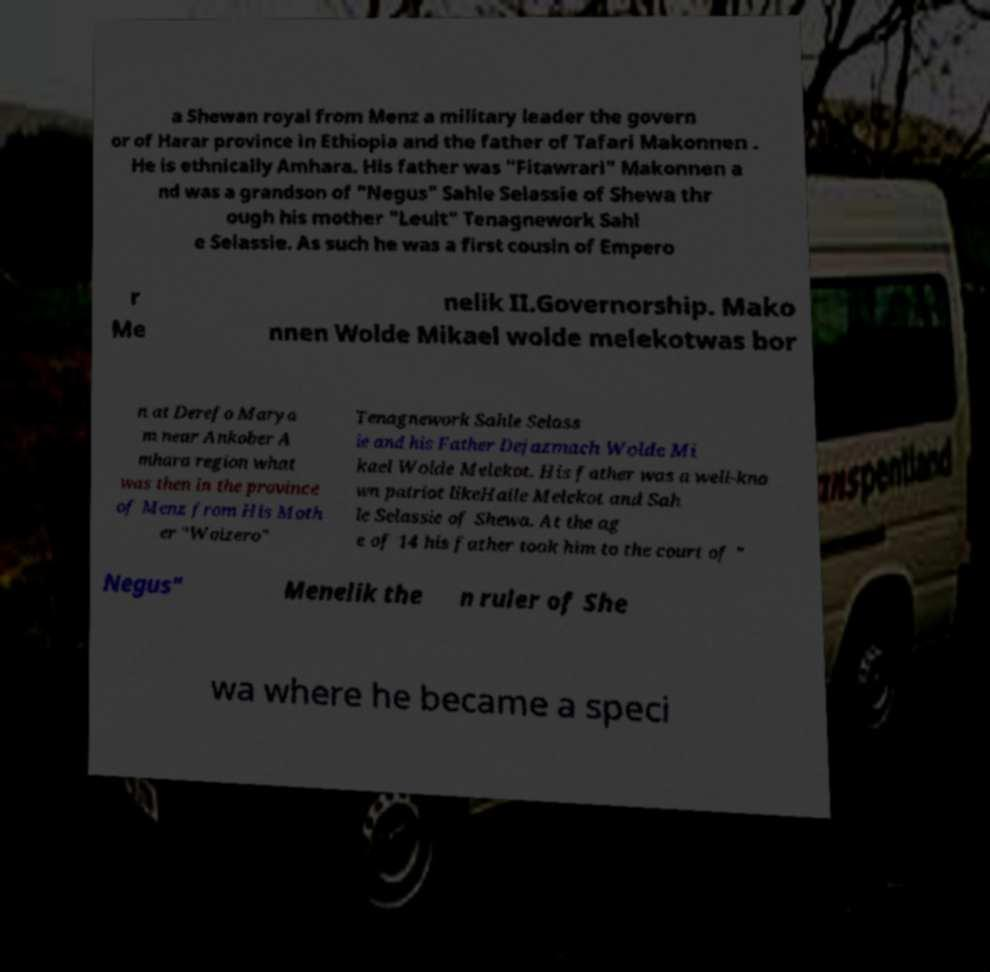There's text embedded in this image that I need extracted. Can you transcribe it verbatim? a Shewan royal from Menz a military leader the govern or of Harar province in Ethiopia and the father of Tafari Makonnen . He is ethnically Amhara. His father was "Fitawrari" Makonnen a nd was a grandson of "Negus" Sahle Selassie of Shewa thr ough his mother "Leult" Tenagnework Sahl e Selassie. As such he was a first cousin of Empero r Me nelik II.Governorship. Mako nnen Wolde Mikael wolde melekotwas bor n at Derefo Marya m near Ankober A mhara region what was then in the province of Menz from His Moth er "Woizero" Tenagnework Sahle Selass ie and his Father Dejazmach Wolde Mi kael Wolde Melekot. His father was a well-kno wn patriot likeHaile Melekot and Sah le Selassie of Shewa. At the ag e of 14 his father took him to the court of " Negus" Menelik the n ruler of She wa where he became a speci 